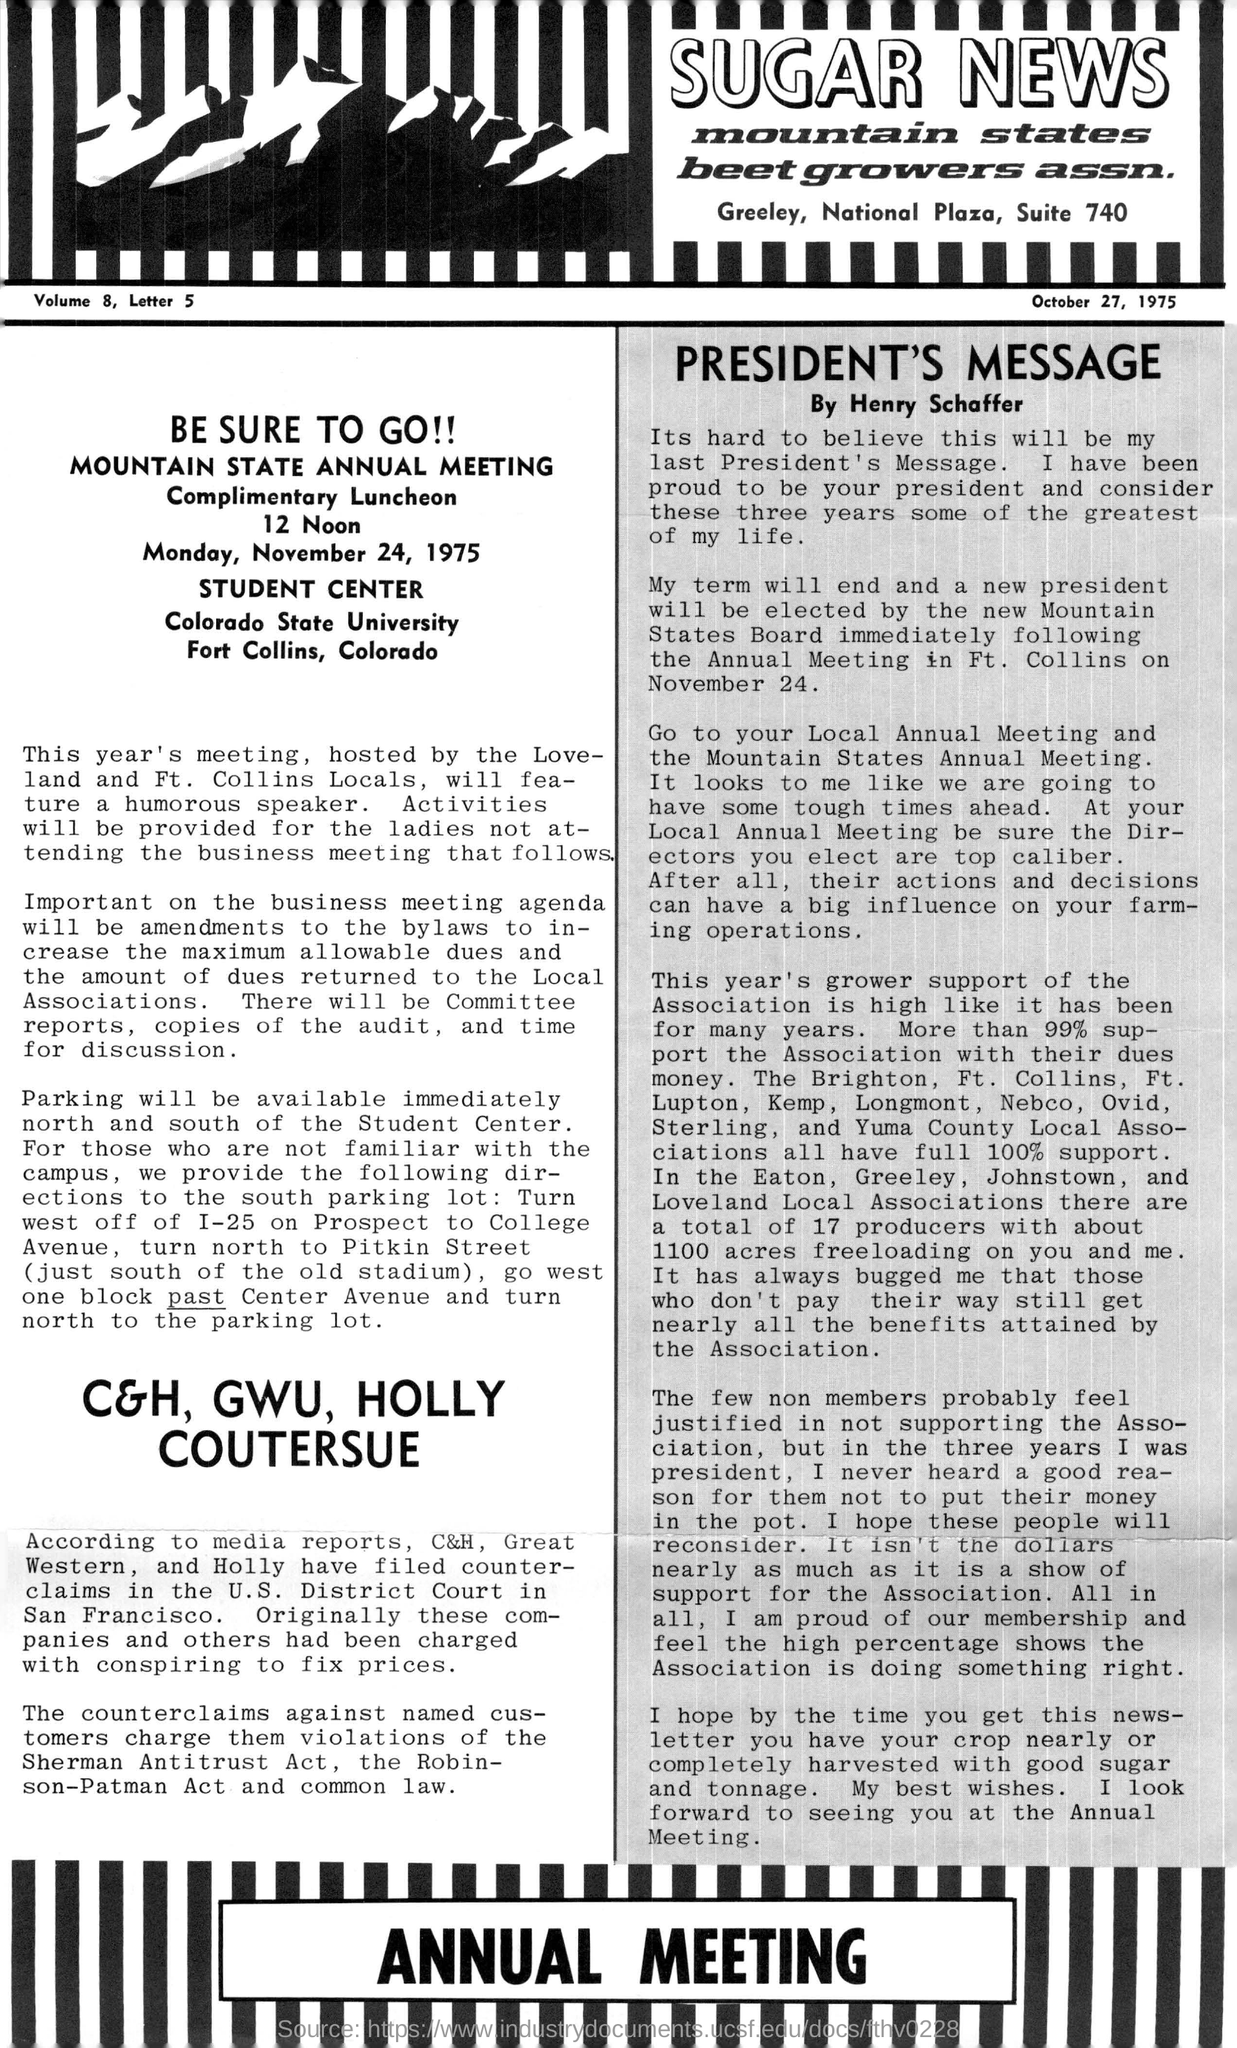Give some essential details in this illustration. The Mountain State Annual Meeting was hosted by the Love-land and Ft. Collins Locals. The Mountain State Annual Meeting was held on Monday, November 24, 1975. 